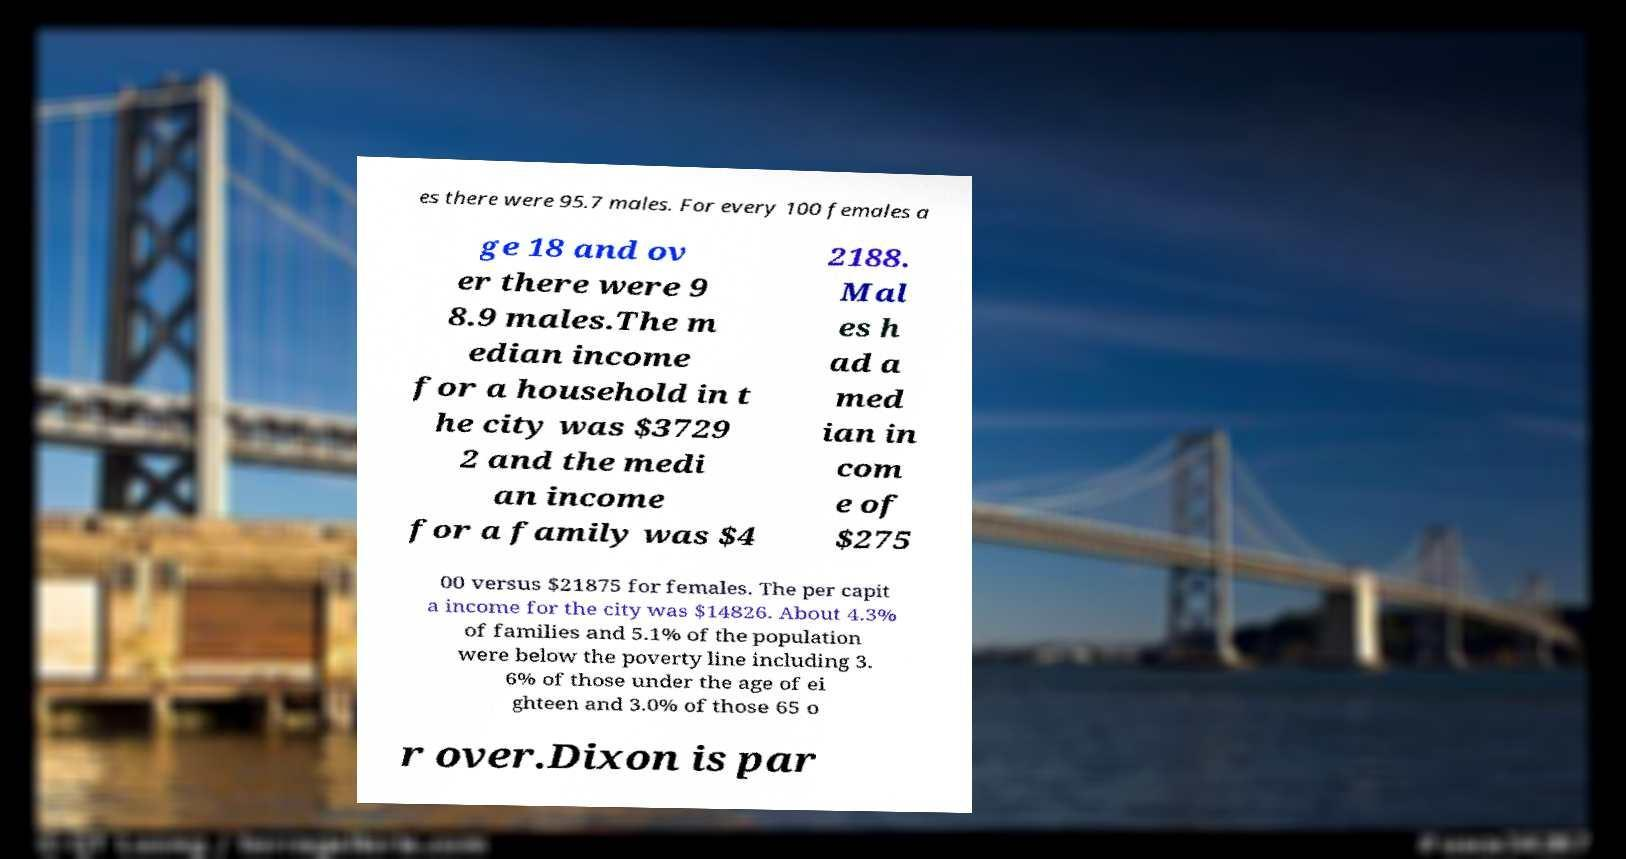For documentation purposes, I need the text within this image transcribed. Could you provide that? es there were 95.7 males. For every 100 females a ge 18 and ov er there were 9 8.9 males.The m edian income for a household in t he city was $3729 2 and the medi an income for a family was $4 2188. Mal es h ad a med ian in com e of $275 00 versus $21875 for females. The per capit a income for the city was $14826. About 4.3% of families and 5.1% of the population were below the poverty line including 3. 6% of those under the age of ei ghteen and 3.0% of those 65 o r over.Dixon is par 